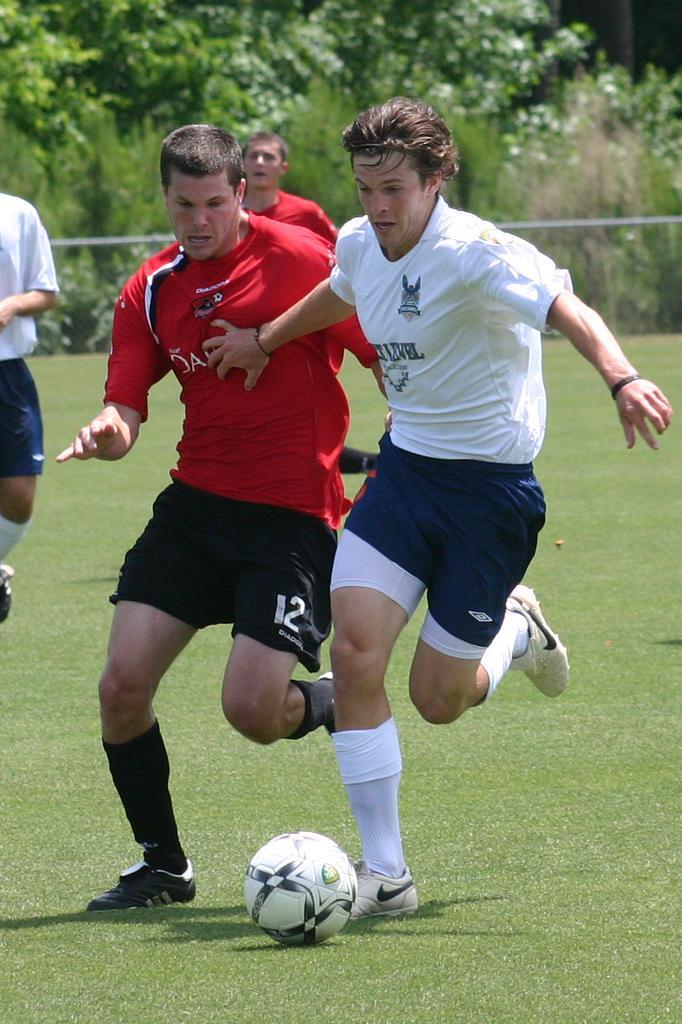Can you describe this image briefly? This image is taken outdoors. At the bottom of the image there is a ground with grass on it. In the background there are a few trees and plants on the ground. There is a fence. On the left side of the image a man is walking on the ground. In the middle of the image three men are running on the ground to kick a football. 